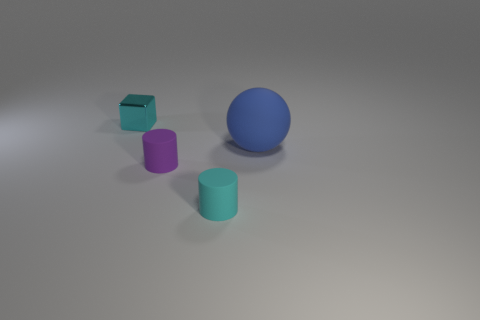Are there more tiny cyan objects in front of the small cyan shiny object than large purple cylinders?
Provide a succinct answer. Yes. What is the material of the small cyan thing in front of the small cyan thing left of the tiny cyan thing that is in front of the cyan cube?
Keep it short and to the point. Rubber. Do the blue sphere and the small cyan thing that is left of the purple cylinder have the same material?
Offer a very short reply. No. Is there anything else that has the same material as the tiny cyan block?
Offer a terse response. No. Is the number of tiny matte objects on the right side of the small cyan metallic block greater than the number of blue balls that are in front of the tiny cyan rubber cylinder?
Your answer should be compact. Yes. The purple object that is the same material as the ball is what shape?
Offer a terse response. Cylinder. What number of other objects are the same shape as the large blue matte object?
Your response must be concise. 0. What shape is the small cyan object in front of the block?
Provide a short and direct response. Cylinder. The big object is what color?
Offer a terse response. Blue. What number of other things are there of the same size as the blue thing?
Your answer should be very brief. 0. 